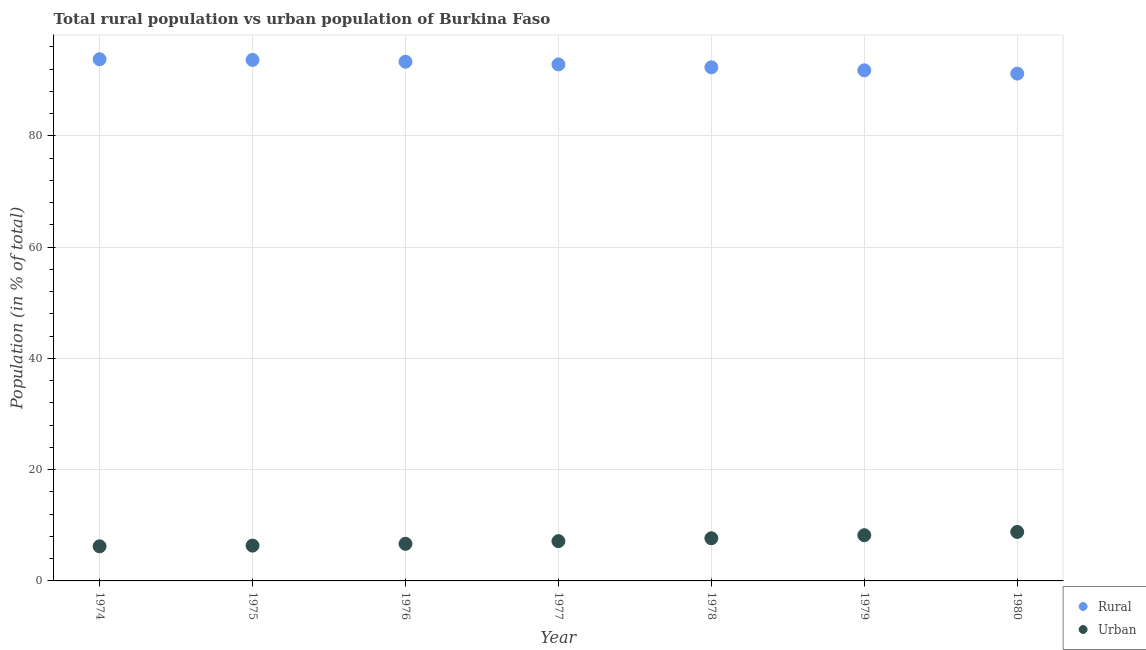Is the number of dotlines equal to the number of legend labels?
Offer a very short reply. Yes. What is the rural population in 1975?
Make the answer very short. 93.65. Across all years, what is the maximum rural population?
Offer a very short reply. 93.78. Across all years, what is the minimum urban population?
Make the answer very short. 6.22. In which year was the rural population maximum?
Your answer should be very brief. 1974. What is the total urban population in the graph?
Provide a short and direct response. 51.08. What is the difference between the rural population in 1975 and that in 1976?
Your answer should be compact. 0.32. What is the difference between the urban population in 1974 and the rural population in 1980?
Offer a terse response. -84.97. What is the average urban population per year?
Keep it short and to the point. 7.3. In the year 1975, what is the difference between the rural population and urban population?
Offer a very short reply. 87.31. In how many years, is the rural population greater than 20 %?
Make the answer very short. 7. What is the ratio of the urban population in 1974 to that in 1978?
Your response must be concise. 0.81. Is the rural population in 1979 less than that in 1980?
Your answer should be very brief. No. Is the difference between the rural population in 1975 and 1976 greater than the difference between the urban population in 1975 and 1976?
Your response must be concise. Yes. What is the difference between the highest and the second highest urban population?
Keep it short and to the point. 0.59. What is the difference between the highest and the lowest rural population?
Provide a succinct answer. 2.58. Does the urban population monotonically increase over the years?
Provide a short and direct response. Yes. How many years are there in the graph?
Your answer should be compact. 7. Does the graph contain any zero values?
Provide a short and direct response. No. Does the graph contain grids?
Your response must be concise. Yes. What is the title of the graph?
Offer a very short reply. Total rural population vs urban population of Burkina Faso. Does "Gasoline" appear as one of the legend labels in the graph?
Provide a short and direct response. No. What is the label or title of the X-axis?
Provide a short and direct response. Year. What is the label or title of the Y-axis?
Provide a succinct answer. Population (in % of total). What is the Population (in % of total) in Rural in 1974?
Your answer should be very brief. 93.78. What is the Population (in % of total) of Urban in 1974?
Offer a very short reply. 6.22. What is the Population (in % of total) of Rural in 1975?
Make the answer very short. 93.65. What is the Population (in % of total) of Urban in 1975?
Offer a terse response. 6.35. What is the Population (in % of total) of Rural in 1976?
Offer a terse response. 93.33. What is the Population (in % of total) of Urban in 1976?
Your answer should be compact. 6.67. What is the Population (in % of total) in Rural in 1977?
Your response must be concise. 92.85. What is the Population (in % of total) of Urban in 1977?
Offer a very short reply. 7.15. What is the Population (in % of total) of Rural in 1978?
Provide a short and direct response. 92.33. What is the Population (in % of total) of Urban in 1978?
Offer a terse response. 7.67. What is the Population (in % of total) in Rural in 1979?
Your answer should be very brief. 91.78. What is the Population (in % of total) of Urban in 1979?
Offer a terse response. 8.22. What is the Population (in % of total) in Rural in 1980?
Your answer should be very brief. 91.19. What is the Population (in % of total) of Urban in 1980?
Give a very brief answer. 8.8. Across all years, what is the maximum Population (in % of total) of Rural?
Offer a terse response. 93.78. Across all years, what is the maximum Population (in % of total) in Urban?
Make the answer very short. 8.8. Across all years, what is the minimum Population (in % of total) of Rural?
Your answer should be very brief. 91.19. Across all years, what is the minimum Population (in % of total) of Urban?
Keep it short and to the point. 6.22. What is the total Population (in % of total) in Rural in the graph?
Offer a very short reply. 648.92. What is the total Population (in % of total) in Urban in the graph?
Offer a very short reply. 51.08. What is the difference between the Population (in % of total) in Urban in 1974 and that in 1975?
Offer a very short reply. -0.12. What is the difference between the Population (in % of total) in Rural in 1974 and that in 1976?
Ensure brevity in your answer.  0.45. What is the difference between the Population (in % of total) in Urban in 1974 and that in 1976?
Keep it short and to the point. -0.45. What is the difference between the Population (in % of total) in Rural in 1974 and that in 1977?
Offer a very short reply. 0.93. What is the difference between the Population (in % of total) in Urban in 1974 and that in 1977?
Offer a terse response. -0.93. What is the difference between the Population (in % of total) in Rural in 1974 and that in 1978?
Make the answer very short. 1.45. What is the difference between the Population (in % of total) in Urban in 1974 and that in 1978?
Offer a very short reply. -1.45. What is the difference between the Population (in % of total) in Rural in 1974 and that in 1979?
Give a very brief answer. 2. What is the difference between the Population (in % of total) in Urban in 1974 and that in 1979?
Your response must be concise. -2. What is the difference between the Population (in % of total) of Rural in 1974 and that in 1980?
Your answer should be very brief. 2.58. What is the difference between the Population (in % of total) of Urban in 1974 and that in 1980?
Make the answer very short. -2.58. What is the difference between the Population (in % of total) in Rural in 1975 and that in 1976?
Your answer should be very brief. 0.32. What is the difference between the Population (in % of total) of Urban in 1975 and that in 1976?
Offer a very short reply. -0.32. What is the difference between the Population (in % of total) in Rural in 1975 and that in 1977?
Your response must be concise. 0.8. What is the difference between the Population (in % of total) in Urban in 1975 and that in 1977?
Your answer should be compact. -0.8. What is the difference between the Population (in % of total) in Rural in 1975 and that in 1978?
Give a very brief answer. 1.32. What is the difference between the Population (in % of total) of Urban in 1975 and that in 1978?
Your answer should be compact. -1.32. What is the difference between the Population (in % of total) in Rural in 1975 and that in 1979?
Offer a terse response. 1.87. What is the difference between the Population (in % of total) in Urban in 1975 and that in 1979?
Keep it short and to the point. -1.87. What is the difference between the Population (in % of total) of Rural in 1975 and that in 1980?
Offer a very short reply. 2.46. What is the difference between the Population (in % of total) of Urban in 1975 and that in 1980?
Give a very brief answer. -2.46. What is the difference between the Population (in % of total) in Rural in 1976 and that in 1977?
Give a very brief answer. 0.48. What is the difference between the Population (in % of total) of Urban in 1976 and that in 1977?
Give a very brief answer. -0.48. What is the difference between the Population (in % of total) of Urban in 1976 and that in 1978?
Offer a terse response. -1. What is the difference between the Population (in % of total) of Rural in 1976 and that in 1979?
Your response must be concise. 1.55. What is the difference between the Population (in % of total) of Urban in 1976 and that in 1979?
Offer a terse response. -1.55. What is the difference between the Population (in % of total) in Rural in 1976 and that in 1980?
Your answer should be compact. 2.14. What is the difference between the Population (in % of total) in Urban in 1976 and that in 1980?
Provide a succinct answer. -2.14. What is the difference between the Population (in % of total) of Rural in 1977 and that in 1978?
Provide a short and direct response. 0.52. What is the difference between the Population (in % of total) of Urban in 1977 and that in 1978?
Keep it short and to the point. -0.52. What is the difference between the Population (in % of total) in Rural in 1977 and that in 1979?
Make the answer very short. 1.07. What is the difference between the Population (in % of total) of Urban in 1977 and that in 1979?
Your answer should be very brief. -1.07. What is the difference between the Population (in % of total) of Rural in 1977 and that in 1980?
Provide a short and direct response. 1.65. What is the difference between the Population (in % of total) in Urban in 1977 and that in 1980?
Ensure brevity in your answer.  -1.65. What is the difference between the Population (in % of total) of Rural in 1978 and that in 1979?
Ensure brevity in your answer.  0.55. What is the difference between the Population (in % of total) of Urban in 1978 and that in 1979?
Your answer should be compact. -0.55. What is the difference between the Population (in % of total) of Rural in 1978 and that in 1980?
Your response must be concise. 1.14. What is the difference between the Population (in % of total) of Urban in 1978 and that in 1980?
Offer a terse response. -1.14. What is the difference between the Population (in % of total) of Rural in 1979 and that in 1980?
Your answer should be compact. 0.59. What is the difference between the Population (in % of total) in Urban in 1979 and that in 1980?
Provide a succinct answer. -0.59. What is the difference between the Population (in % of total) in Rural in 1974 and the Population (in % of total) in Urban in 1975?
Ensure brevity in your answer.  87.43. What is the difference between the Population (in % of total) in Rural in 1974 and the Population (in % of total) in Urban in 1976?
Provide a short and direct response. 87.11. What is the difference between the Population (in % of total) in Rural in 1974 and the Population (in % of total) in Urban in 1977?
Provide a succinct answer. 86.63. What is the difference between the Population (in % of total) in Rural in 1974 and the Population (in % of total) in Urban in 1978?
Give a very brief answer. 86.11. What is the difference between the Population (in % of total) in Rural in 1974 and the Population (in % of total) in Urban in 1979?
Make the answer very short. 85.56. What is the difference between the Population (in % of total) of Rural in 1974 and the Population (in % of total) of Urban in 1980?
Provide a succinct answer. 84.97. What is the difference between the Population (in % of total) of Rural in 1975 and the Population (in % of total) of Urban in 1976?
Offer a very short reply. 86.98. What is the difference between the Population (in % of total) in Rural in 1975 and the Population (in % of total) in Urban in 1977?
Ensure brevity in your answer.  86.5. What is the difference between the Population (in % of total) in Rural in 1975 and the Population (in % of total) in Urban in 1978?
Give a very brief answer. 85.98. What is the difference between the Population (in % of total) of Rural in 1975 and the Population (in % of total) of Urban in 1979?
Your answer should be compact. 85.44. What is the difference between the Population (in % of total) of Rural in 1975 and the Population (in % of total) of Urban in 1980?
Your answer should be compact. 84.85. What is the difference between the Population (in % of total) in Rural in 1976 and the Population (in % of total) in Urban in 1977?
Ensure brevity in your answer.  86.18. What is the difference between the Population (in % of total) of Rural in 1976 and the Population (in % of total) of Urban in 1978?
Provide a succinct answer. 85.66. What is the difference between the Population (in % of total) of Rural in 1976 and the Population (in % of total) of Urban in 1979?
Your answer should be compact. 85.11. What is the difference between the Population (in % of total) in Rural in 1976 and the Population (in % of total) in Urban in 1980?
Make the answer very short. 84.53. What is the difference between the Population (in % of total) of Rural in 1977 and the Population (in % of total) of Urban in 1978?
Ensure brevity in your answer.  85.18. What is the difference between the Population (in % of total) of Rural in 1977 and the Population (in % of total) of Urban in 1979?
Ensure brevity in your answer.  84.63. What is the difference between the Population (in % of total) in Rural in 1977 and the Population (in % of total) in Urban in 1980?
Make the answer very short. 84.04. What is the difference between the Population (in % of total) in Rural in 1978 and the Population (in % of total) in Urban in 1979?
Offer a terse response. 84.11. What is the difference between the Population (in % of total) in Rural in 1978 and the Population (in % of total) in Urban in 1980?
Offer a very short reply. 83.53. What is the difference between the Population (in % of total) of Rural in 1979 and the Population (in % of total) of Urban in 1980?
Your response must be concise. 82.98. What is the average Population (in % of total) in Rural per year?
Provide a succinct answer. 92.7. What is the average Population (in % of total) in Urban per year?
Your answer should be compact. 7.3. In the year 1974, what is the difference between the Population (in % of total) of Rural and Population (in % of total) of Urban?
Keep it short and to the point. 87.56. In the year 1975, what is the difference between the Population (in % of total) of Rural and Population (in % of total) of Urban?
Offer a very short reply. 87.31. In the year 1976, what is the difference between the Population (in % of total) in Rural and Population (in % of total) in Urban?
Make the answer very short. 86.66. In the year 1977, what is the difference between the Population (in % of total) of Rural and Population (in % of total) of Urban?
Your answer should be compact. 85.7. In the year 1978, what is the difference between the Population (in % of total) in Rural and Population (in % of total) in Urban?
Your response must be concise. 84.66. In the year 1979, what is the difference between the Population (in % of total) in Rural and Population (in % of total) in Urban?
Make the answer very short. 83.56. In the year 1980, what is the difference between the Population (in % of total) of Rural and Population (in % of total) of Urban?
Keep it short and to the point. 82.39. What is the ratio of the Population (in % of total) in Urban in 1974 to that in 1975?
Your answer should be compact. 0.98. What is the ratio of the Population (in % of total) of Urban in 1974 to that in 1976?
Give a very brief answer. 0.93. What is the ratio of the Population (in % of total) in Urban in 1974 to that in 1977?
Give a very brief answer. 0.87. What is the ratio of the Population (in % of total) of Rural in 1974 to that in 1978?
Ensure brevity in your answer.  1.02. What is the ratio of the Population (in % of total) of Urban in 1974 to that in 1978?
Offer a very short reply. 0.81. What is the ratio of the Population (in % of total) in Rural in 1974 to that in 1979?
Provide a short and direct response. 1.02. What is the ratio of the Population (in % of total) of Urban in 1974 to that in 1979?
Make the answer very short. 0.76. What is the ratio of the Population (in % of total) of Rural in 1974 to that in 1980?
Provide a succinct answer. 1.03. What is the ratio of the Population (in % of total) in Urban in 1974 to that in 1980?
Keep it short and to the point. 0.71. What is the ratio of the Population (in % of total) of Urban in 1975 to that in 1976?
Make the answer very short. 0.95. What is the ratio of the Population (in % of total) in Rural in 1975 to that in 1977?
Provide a short and direct response. 1.01. What is the ratio of the Population (in % of total) of Urban in 1975 to that in 1977?
Offer a very short reply. 0.89. What is the ratio of the Population (in % of total) in Rural in 1975 to that in 1978?
Your response must be concise. 1.01. What is the ratio of the Population (in % of total) in Urban in 1975 to that in 1978?
Provide a short and direct response. 0.83. What is the ratio of the Population (in % of total) in Rural in 1975 to that in 1979?
Your response must be concise. 1.02. What is the ratio of the Population (in % of total) in Urban in 1975 to that in 1979?
Your answer should be very brief. 0.77. What is the ratio of the Population (in % of total) in Urban in 1975 to that in 1980?
Keep it short and to the point. 0.72. What is the ratio of the Population (in % of total) of Rural in 1976 to that in 1977?
Ensure brevity in your answer.  1.01. What is the ratio of the Population (in % of total) of Urban in 1976 to that in 1977?
Provide a short and direct response. 0.93. What is the ratio of the Population (in % of total) in Rural in 1976 to that in 1978?
Keep it short and to the point. 1.01. What is the ratio of the Population (in % of total) of Urban in 1976 to that in 1978?
Provide a short and direct response. 0.87. What is the ratio of the Population (in % of total) of Rural in 1976 to that in 1979?
Your response must be concise. 1.02. What is the ratio of the Population (in % of total) in Urban in 1976 to that in 1979?
Keep it short and to the point. 0.81. What is the ratio of the Population (in % of total) in Rural in 1976 to that in 1980?
Your answer should be very brief. 1.02. What is the ratio of the Population (in % of total) of Urban in 1976 to that in 1980?
Offer a very short reply. 0.76. What is the ratio of the Population (in % of total) of Rural in 1977 to that in 1978?
Provide a short and direct response. 1.01. What is the ratio of the Population (in % of total) of Urban in 1977 to that in 1978?
Your answer should be compact. 0.93. What is the ratio of the Population (in % of total) in Rural in 1977 to that in 1979?
Your answer should be very brief. 1.01. What is the ratio of the Population (in % of total) in Urban in 1977 to that in 1979?
Your answer should be compact. 0.87. What is the ratio of the Population (in % of total) in Rural in 1977 to that in 1980?
Your answer should be very brief. 1.02. What is the ratio of the Population (in % of total) of Urban in 1977 to that in 1980?
Keep it short and to the point. 0.81. What is the ratio of the Population (in % of total) of Urban in 1978 to that in 1979?
Your answer should be compact. 0.93. What is the ratio of the Population (in % of total) of Rural in 1978 to that in 1980?
Offer a very short reply. 1.01. What is the ratio of the Population (in % of total) of Urban in 1978 to that in 1980?
Provide a short and direct response. 0.87. What is the ratio of the Population (in % of total) in Rural in 1979 to that in 1980?
Provide a short and direct response. 1.01. What is the ratio of the Population (in % of total) of Urban in 1979 to that in 1980?
Provide a short and direct response. 0.93. What is the difference between the highest and the second highest Population (in % of total) in Urban?
Make the answer very short. 0.59. What is the difference between the highest and the lowest Population (in % of total) in Rural?
Your answer should be very brief. 2.58. What is the difference between the highest and the lowest Population (in % of total) in Urban?
Your answer should be compact. 2.58. 